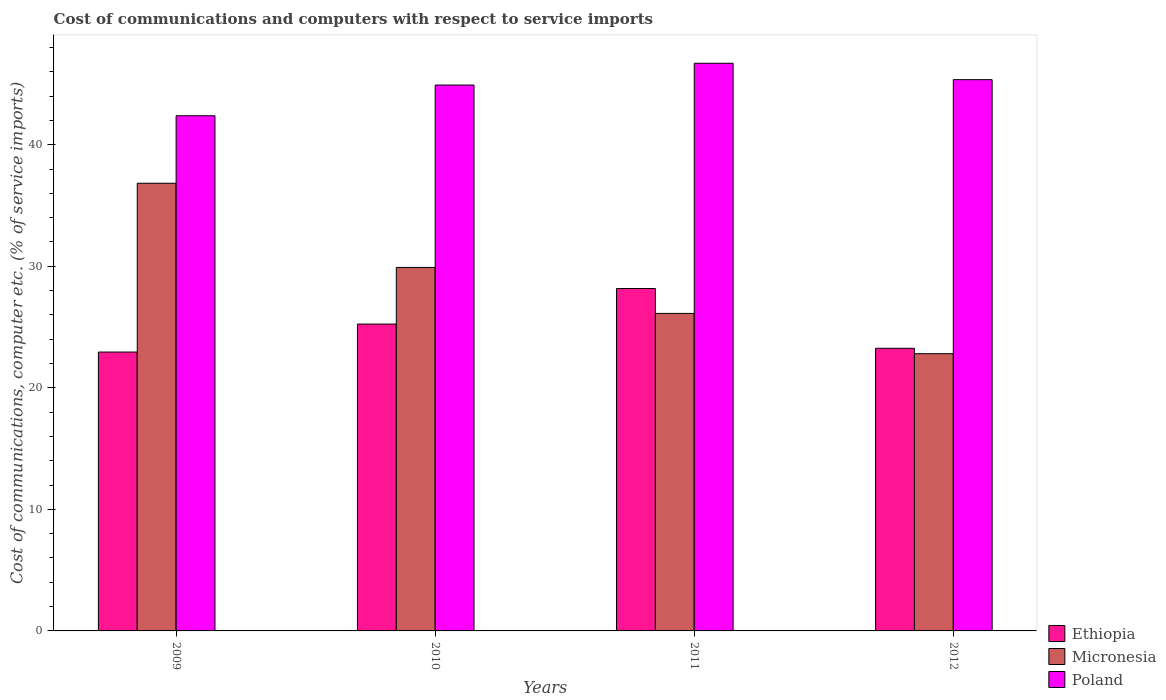How many groups of bars are there?
Provide a succinct answer. 4. How many bars are there on the 3rd tick from the left?
Ensure brevity in your answer.  3. How many bars are there on the 1st tick from the right?
Offer a very short reply. 3. In how many cases, is the number of bars for a given year not equal to the number of legend labels?
Make the answer very short. 0. What is the cost of communications and computers in Micronesia in 2010?
Ensure brevity in your answer.  29.91. Across all years, what is the maximum cost of communications and computers in Micronesia?
Give a very brief answer. 36.83. Across all years, what is the minimum cost of communications and computers in Ethiopia?
Offer a terse response. 22.94. In which year was the cost of communications and computers in Ethiopia minimum?
Provide a short and direct response. 2009. What is the total cost of communications and computers in Micronesia in the graph?
Your answer should be very brief. 115.67. What is the difference between the cost of communications and computers in Micronesia in 2010 and that in 2011?
Your response must be concise. 3.78. What is the difference between the cost of communications and computers in Ethiopia in 2011 and the cost of communications and computers in Poland in 2009?
Give a very brief answer. -14.22. What is the average cost of communications and computers in Poland per year?
Your answer should be very brief. 44.84. In the year 2009, what is the difference between the cost of communications and computers in Poland and cost of communications and computers in Micronesia?
Your answer should be very brief. 5.56. What is the ratio of the cost of communications and computers in Ethiopia in 2010 to that in 2012?
Offer a terse response. 1.09. What is the difference between the highest and the second highest cost of communications and computers in Micronesia?
Your answer should be very brief. 6.92. What is the difference between the highest and the lowest cost of communications and computers in Micronesia?
Your answer should be compact. 14.02. In how many years, is the cost of communications and computers in Poland greater than the average cost of communications and computers in Poland taken over all years?
Keep it short and to the point. 3. What does the 2nd bar from the left in 2011 represents?
Offer a very short reply. Micronesia. What does the 3rd bar from the right in 2010 represents?
Your answer should be compact. Ethiopia. How many bars are there?
Ensure brevity in your answer.  12. Where does the legend appear in the graph?
Your answer should be very brief. Bottom right. How many legend labels are there?
Your answer should be compact. 3. How are the legend labels stacked?
Provide a succinct answer. Vertical. What is the title of the graph?
Offer a very short reply. Cost of communications and computers with respect to service imports. What is the label or title of the Y-axis?
Offer a very short reply. Cost of communications, computer etc. (% of service imports). What is the Cost of communications, computer etc. (% of service imports) in Ethiopia in 2009?
Keep it short and to the point. 22.94. What is the Cost of communications, computer etc. (% of service imports) in Micronesia in 2009?
Provide a short and direct response. 36.83. What is the Cost of communications, computer etc. (% of service imports) of Poland in 2009?
Give a very brief answer. 42.39. What is the Cost of communications, computer etc. (% of service imports) in Ethiopia in 2010?
Make the answer very short. 25.25. What is the Cost of communications, computer etc. (% of service imports) in Micronesia in 2010?
Keep it short and to the point. 29.91. What is the Cost of communications, computer etc. (% of service imports) in Poland in 2010?
Provide a succinct answer. 44.91. What is the Cost of communications, computer etc. (% of service imports) in Ethiopia in 2011?
Offer a terse response. 28.17. What is the Cost of communications, computer etc. (% of service imports) of Micronesia in 2011?
Your answer should be compact. 26.12. What is the Cost of communications, computer etc. (% of service imports) of Poland in 2011?
Provide a short and direct response. 46.71. What is the Cost of communications, computer etc. (% of service imports) in Ethiopia in 2012?
Offer a very short reply. 23.25. What is the Cost of communications, computer etc. (% of service imports) of Micronesia in 2012?
Give a very brief answer. 22.81. What is the Cost of communications, computer etc. (% of service imports) in Poland in 2012?
Keep it short and to the point. 45.36. Across all years, what is the maximum Cost of communications, computer etc. (% of service imports) of Ethiopia?
Your answer should be very brief. 28.17. Across all years, what is the maximum Cost of communications, computer etc. (% of service imports) of Micronesia?
Offer a very short reply. 36.83. Across all years, what is the maximum Cost of communications, computer etc. (% of service imports) of Poland?
Your answer should be very brief. 46.71. Across all years, what is the minimum Cost of communications, computer etc. (% of service imports) in Ethiopia?
Offer a terse response. 22.94. Across all years, what is the minimum Cost of communications, computer etc. (% of service imports) in Micronesia?
Provide a short and direct response. 22.81. Across all years, what is the minimum Cost of communications, computer etc. (% of service imports) of Poland?
Your response must be concise. 42.39. What is the total Cost of communications, computer etc. (% of service imports) of Ethiopia in the graph?
Your answer should be compact. 99.62. What is the total Cost of communications, computer etc. (% of service imports) in Micronesia in the graph?
Your answer should be very brief. 115.67. What is the total Cost of communications, computer etc. (% of service imports) in Poland in the graph?
Offer a terse response. 179.36. What is the difference between the Cost of communications, computer etc. (% of service imports) of Ethiopia in 2009 and that in 2010?
Make the answer very short. -2.3. What is the difference between the Cost of communications, computer etc. (% of service imports) of Micronesia in 2009 and that in 2010?
Your answer should be compact. 6.92. What is the difference between the Cost of communications, computer etc. (% of service imports) of Poland in 2009 and that in 2010?
Your response must be concise. -2.53. What is the difference between the Cost of communications, computer etc. (% of service imports) in Ethiopia in 2009 and that in 2011?
Your answer should be very brief. -5.23. What is the difference between the Cost of communications, computer etc. (% of service imports) of Micronesia in 2009 and that in 2011?
Make the answer very short. 10.71. What is the difference between the Cost of communications, computer etc. (% of service imports) in Poland in 2009 and that in 2011?
Ensure brevity in your answer.  -4.32. What is the difference between the Cost of communications, computer etc. (% of service imports) of Ethiopia in 2009 and that in 2012?
Give a very brief answer. -0.31. What is the difference between the Cost of communications, computer etc. (% of service imports) of Micronesia in 2009 and that in 2012?
Your response must be concise. 14.02. What is the difference between the Cost of communications, computer etc. (% of service imports) of Poland in 2009 and that in 2012?
Your answer should be compact. -2.97. What is the difference between the Cost of communications, computer etc. (% of service imports) in Ethiopia in 2010 and that in 2011?
Make the answer very short. -2.93. What is the difference between the Cost of communications, computer etc. (% of service imports) in Micronesia in 2010 and that in 2011?
Give a very brief answer. 3.78. What is the difference between the Cost of communications, computer etc. (% of service imports) in Poland in 2010 and that in 2011?
Ensure brevity in your answer.  -1.79. What is the difference between the Cost of communications, computer etc. (% of service imports) in Ethiopia in 2010 and that in 2012?
Provide a short and direct response. 1.99. What is the difference between the Cost of communications, computer etc. (% of service imports) in Micronesia in 2010 and that in 2012?
Offer a terse response. 7.1. What is the difference between the Cost of communications, computer etc. (% of service imports) in Poland in 2010 and that in 2012?
Keep it short and to the point. -0.44. What is the difference between the Cost of communications, computer etc. (% of service imports) of Ethiopia in 2011 and that in 2012?
Provide a short and direct response. 4.92. What is the difference between the Cost of communications, computer etc. (% of service imports) of Micronesia in 2011 and that in 2012?
Give a very brief answer. 3.31. What is the difference between the Cost of communications, computer etc. (% of service imports) of Poland in 2011 and that in 2012?
Give a very brief answer. 1.35. What is the difference between the Cost of communications, computer etc. (% of service imports) of Ethiopia in 2009 and the Cost of communications, computer etc. (% of service imports) of Micronesia in 2010?
Provide a succinct answer. -6.96. What is the difference between the Cost of communications, computer etc. (% of service imports) in Ethiopia in 2009 and the Cost of communications, computer etc. (% of service imports) in Poland in 2010?
Provide a short and direct response. -21.97. What is the difference between the Cost of communications, computer etc. (% of service imports) in Micronesia in 2009 and the Cost of communications, computer etc. (% of service imports) in Poland in 2010?
Offer a very short reply. -8.08. What is the difference between the Cost of communications, computer etc. (% of service imports) in Ethiopia in 2009 and the Cost of communications, computer etc. (% of service imports) in Micronesia in 2011?
Your answer should be compact. -3.18. What is the difference between the Cost of communications, computer etc. (% of service imports) of Ethiopia in 2009 and the Cost of communications, computer etc. (% of service imports) of Poland in 2011?
Give a very brief answer. -23.76. What is the difference between the Cost of communications, computer etc. (% of service imports) in Micronesia in 2009 and the Cost of communications, computer etc. (% of service imports) in Poland in 2011?
Make the answer very short. -9.87. What is the difference between the Cost of communications, computer etc. (% of service imports) of Ethiopia in 2009 and the Cost of communications, computer etc. (% of service imports) of Micronesia in 2012?
Your response must be concise. 0.13. What is the difference between the Cost of communications, computer etc. (% of service imports) of Ethiopia in 2009 and the Cost of communications, computer etc. (% of service imports) of Poland in 2012?
Give a very brief answer. -22.41. What is the difference between the Cost of communications, computer etc. (% of service imports) in Micronesia in 2009 and the Cost of communications, computer etc. (% of service imports) in Poland in 2012?
Your answer should be compact. -8.52. What is the difference between the Cost of communications, computer etc. (% of service imports) of Ethiopia in 2010 and the Cost of communications, computer etc. (% of service imports) of Micronesia in 2011?
Give a very brief answer. -0.88. What is the difference between the Cost of communications, computer etc. (% of service imports) in Ethiopia in 2010 and the Cost of communications, computer etc. (% of service imports) in Poland in 2011?
Give a very brief answer. -21.46. What is the difference between the Cost of communications, computer etc. (% of service imports) of Micronesia in 2010 and the Cost of communications, computer etc. (% of service imports) of Poland in 2011?
Ensure brevity in your answer.  -16.8. What is the difference between the Cost of communications, computer etc. (% of service imports) of Ethiopia in 2010 and the Cost of communications, computer etc. (% of service imports) of Micronesia in 2012?
Offer a very short reply. 2.44. What is the difference between the Cost of communications, computer etc. (% of service imports) of Ethiopia in 2010 and the Cost of communications, computer etc. (% of service imports) of Poland in 2012?
Your answer should be very brief. -20.11. What is the difference between the Cost of communications, computer etc. (% of service imports) of Micronesia in 2010 and the Cost of communications, computer etc. (% of service imports) of Poland in 2012?
Give a very brief answer. -15.45. What is the difference between the Cost of communications, computer etc. (% of service imports) in Ethiopia in 2011 and the Cost of communications, computer etc. (% of service imports) in Micronesia in 2012?
Provide a short and direct response. 5.36. What is the difference between the Cost of communications, computer etc. (% of service imports) of Ethiopia in 2011 and the Cost of communications, computer etc. (% of service imports) of Poland in 2012?
Your response must be concise. -17.18. What is the difference between the Cost of communications, computer etc. (% of service imports) of Micronesia in 2011 and the Cost of communications, computer etc. (% of service imports) of Poland in 2012?
Provide a short and direct response. -19.23. What is the average Cost of communications, computer etc. (% of service imports) in Ethiopia per year?
Offer a terse response. 24.9. What is the average Cost of communications, computer etc. (% of service imports) of Micronesia per year?
Keep it short and to the point. 28.92. What is the average Cost of communications, computer etc. (% of service imports) of Poland per year?
Make the answer very short. 44.84. In the year 2009, what is the difference between the Cost of communications, computer etc. (% of service imports) in Ethiopia and Cost of communications, computer etc. (% of service imports) in Micronesia?
Give a very brief answer. -13.89. In the year 2009, what is the difference between the Cost of communications, computer etc. (% of service imports) of Ethiopia and Cost of communications, computer etc. (% of service imports) of Poland?
Offer a very short reply. -19.44. In the year 2009, what is the difference between the Cost of communications, computer etc. (% of service imports) of Micronesia and Cost of communications, computer etc. (% of service imports) of Poland?
Make the answer very short. -5.56. In the year 2010, what is the difference between the Cost of communications, computer etc. (% of service imports) of Ethiopia and Cost of communications, computer etc. (% of service imports) of Micronesia?
Your answer should be compact. -4.66. In the year 2010, what is the difference between the Cost of communications, computer etc. (% of service imports) of Ethiopia and Cost of communications, computer etc. (% of service imports) of Poland?
Provide a succinct answer. -19.67. In the year 2010, what is the difference between the Cost of communications, computer etc. (% of service imports) in Micronesia and Cost of communications, computer etc. (% of service imports) in Poland?
Give a very brief answer. -15.01. In the year 2011, what is the difference between the Cost of communications, computer etc. (% of service imports) of Ethiopia and Cost of communications, computer etc. (% of service imports) of Micronesia?
Offer a terse response. 2.05. In the year 2011, what is the difference between the Cost of communications, computer etc. (% of service imports) of Ethiopia and Cost of communications, computer etc. (% of service imports) of Poland?
Offer a very short reply. -18.53. In the year 2011, what is the difference between the Cost of communications, computer etc. (% of service imports) of Micronesia and Cost of communications, computer etc. (% of service imports) of Poland?
Keep it short and to the point. -20.58. In the year 2012, what is the difference between the Cost of communications, computer etc. (% of service imports) in Ethiopia and Cost of communications, computer etc. (% of service imports) in Micronesia?
Make the answer very short. 0.44. In the year 2012, what is the difference between the Cost of communications, computer etc. (% of service imports) of Ethiopia and Cost of communications, computer etc. (% of service imports) of Poland?
Offer a terse response. -22.1. In the year 2012, what is the difference between the Cost of communications, computer etc. (% of service imports) in Micronesia and Cost of communications, computer etc. (% of service imports) in Poland?
Provide a succinct answer. -22.55. What is the ratio of the Cost of communications, computer etc. (% of service imports) of Ethiopia in 2009 to that in 2010?
Provide a succinct answer. 0.91. What is the ratio of the Cost of communications, computer etc. (% of service imports) in Micronesia in 2009 to that in 2010?
Provide a succinct answer. 1.23. What is the ratio of the Cost of communications, computer etc. (% of service imports) in Poland in 2009 to that in 2010?
Your answer should be compact. 0.94. What is the ratio of the Cost of communications, computer etc. (% of service imports) of Ethiopia in 2009 to that in 2011?
Your answer should be compact. 0.81. What is the ratio of the Cost of communications, computer etc. (% of service imports) in Micronesia in 2009 to that in 2011?
Give a very brief answer. 1.41. What is the ratio of the Cost of communications, computer etc. (% of service imports) of Poland in 2009 to that in 2011?
Provide a short and direct response. 0.91. What is the ratio of the Cost of communications, computer etc. (% of service imports) of Ethiopia in 2009 to that in 2012?
Your response must be concise. 0.99. What is the ratio of the Cost of communications, computer etc. (% of service imports) in Micronesia in 2009 to that in 2012?
Provide a succinct answer. 1.61. What is the ratio of the Cost of communications, computer etc. (% of service imports) in Poland in 2009 to that in 2012?
Ensure brevity in your answer.  0.93. What is the ratio of the Cost of communications, computer etc. (% of service imports) of Ethiopia in 2010 to that in 2011?
Give a very brief answer. 0.9. What is the ratio of the Cost of communications, computer etc. (% of service imports) in Micronesia in 2010 to that in 2011?
Offer a very short reply. 1.14. What is the ratio of the Cost of communications, computer etc. (% of service imports) in Poland in 2010 to that in 2011?
Your answer should be compact. 0.96. What is the ratio of the Cost of communications, computer etc. (% of service imports) in Ethiopia in 2010 to that in 2012?
Keep it short and to the point. 1.09. What is the ratio of the Cost of communications, computer etc. (% of service imports) in Micronesia in 2010 to that in 2012?
Ensure brevity in your answer.  1.31. What is the ratio of the Cost of communications, computer etc. (% of service imports) in Poland in 2010 to that in 2012?
Your answer should be very brief. 0.99. What is the ratio of the Cost of communications, computer etc. (% of service imports) of Ethiopia in 2011 to that in 2012?
Make the answer very short. 1.21. What is the ratio of the Cost of communications, computer etc. (% of service imports) in Micronesia in 2011 to that in 2012?
Keep it short and to the point. 1.15. What is the ratio of the Cost of communications, computer etc. (% of service imports) in Poland in 2011 to that in 2012?
Provide a short and direct response. 1.03. What is the difference between the highest and the second highest Cost of communications, computer etc. (% of service imports) of Ethiopia?
Your response must be concise. 2.93. What is the difference between the highest and the second highest Cost of communications, computer etc. (% of service imports) of Micronesia?
Provide a succinct answer. 6.92. What is the difference between the highest and the second highest Cost of communications, computer etc. (% of service imports) of Poland?
Make the answer very short. 1.35. What is the difference between the highest and the lowest Cost of communications, computer etc. (% of service imports) in Ethiopia?
Provide a succinct answer. 5.23. What is the difference between the highest and the lowest Cost of communications, computer etc. (% of service imports) of Micronesia?
Ensure brevity in your answer.  14.02. What is the difference between the highest and the lowest Cost of communications, computer etc. (% of service imports) in Poland?
Provide a short and direct response. 4.32. 